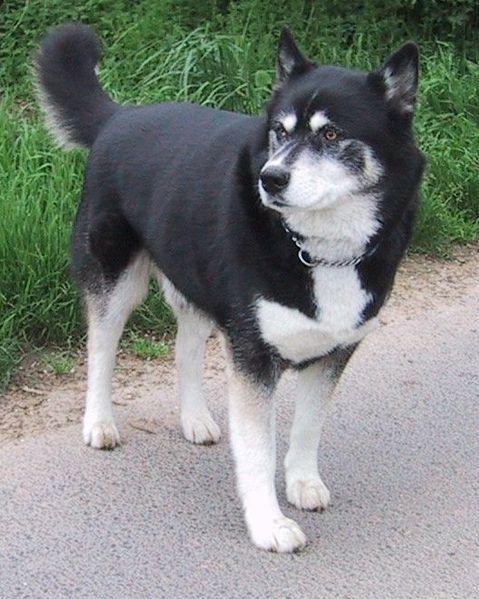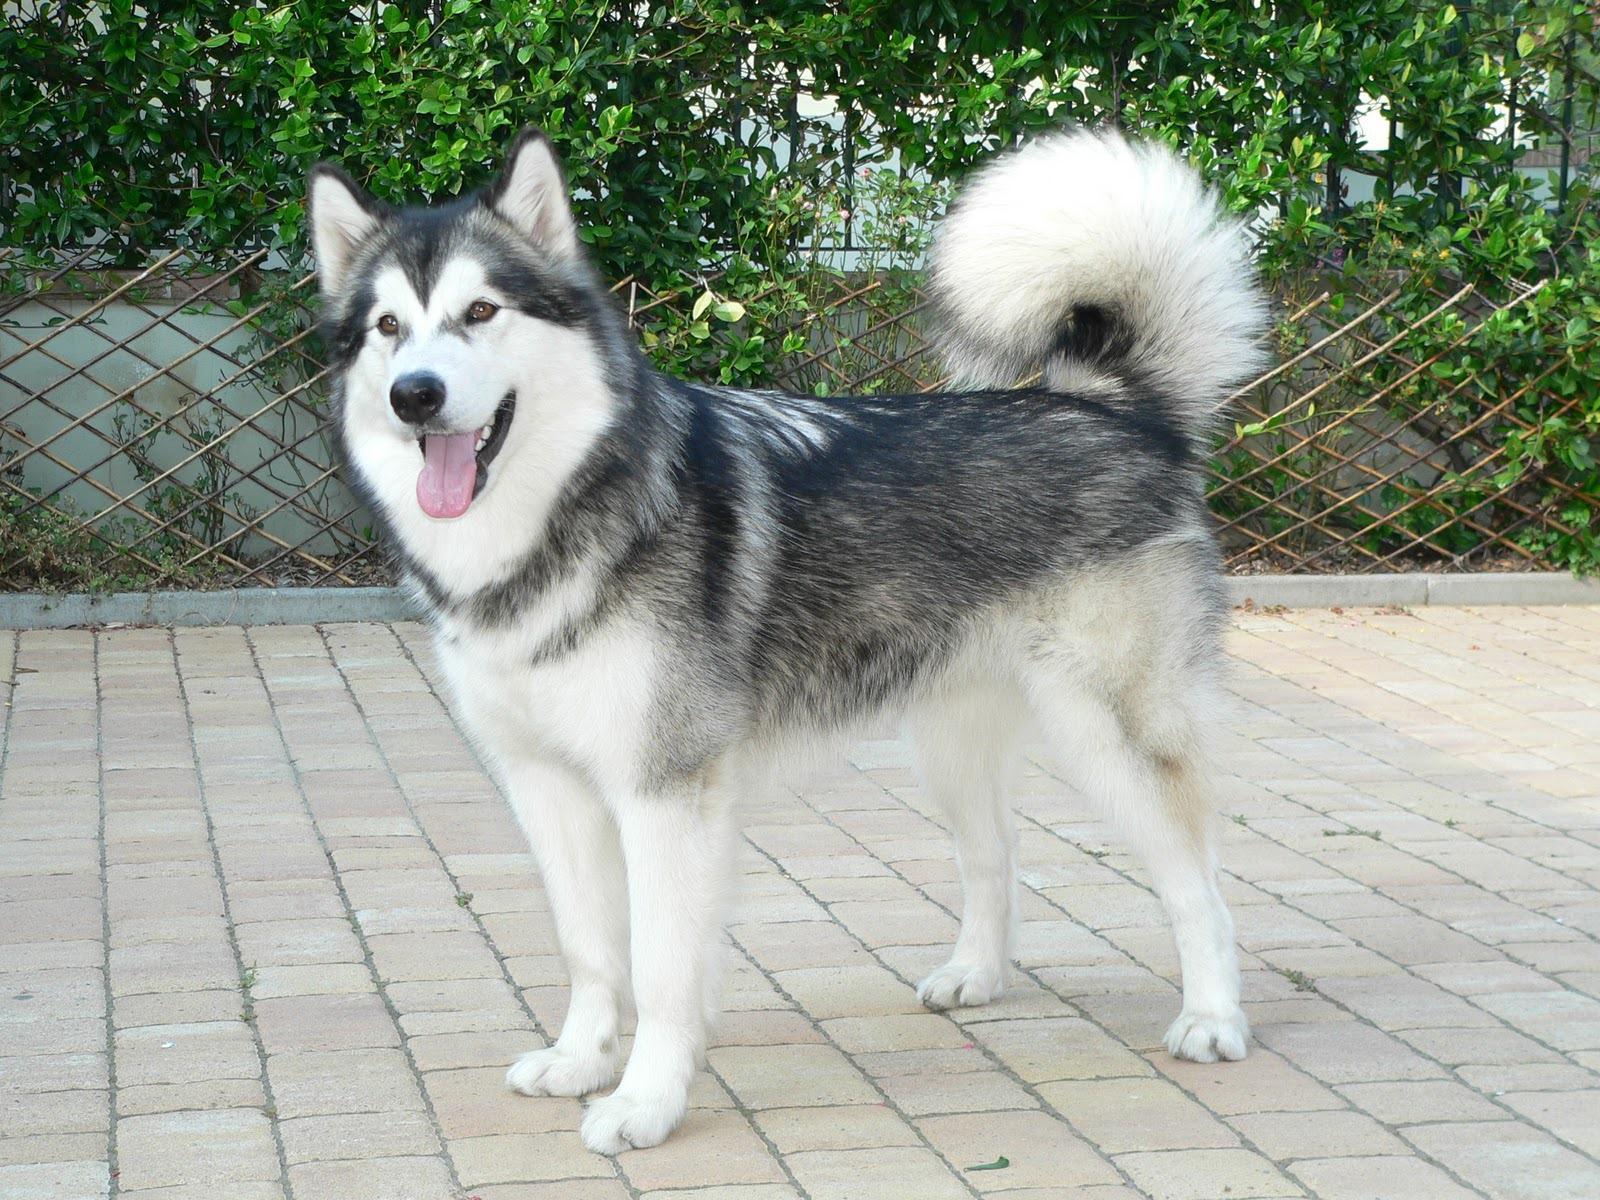The first image is the image on the left, the second image is the image on the right. Analyze the images presented: Is the assertion "Each image contains one adult husky, and one of the dogs pictured stands on all fours with its mouth open and tongue hanging out." valid? Answer yes or no. Yes. The first image is the image on the left, the second image is the image on the right. Examine the images to the left and right. Is the description "The dog in the image on the left is standing in the grass." accurate? Answer yes or no. No. 